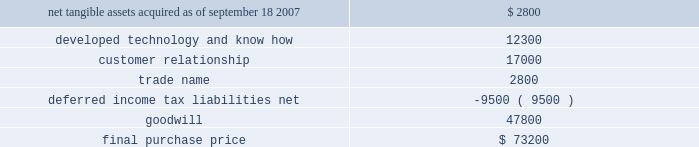Hologic , inc .
Notes to consolidated financial statements ( continued ) ( in thousands , except per share data ) fiscal 2007 acquisition : acquisition of biolucent , inc .
On september 18 , 2007 the company completed the acquisition of biolucent , inc .
( 201cbiolucent 201d ) pursuant to a definitive agreement dated june 20 , 2007 .
The results of operations for biolucent have been included in the company 2019s consolidated financial statements from the date of acquisition as part of its mammography/breast care business segment .
The company has concluded that the acquisition of biolucent does not represent a material business combination and therefore no pro forma financial information has been provided herein .
Biolucent , previously located in aliso viejo , california , develops , markets and sells mammopad breast cushions to decrease the discomfort associated with mammography .
Prior to the acquisition , biolucent 2019s primary research and development efforts were directed at its brachytherapy business which was focused on breast cancer therapy .
Prior to the acquisition , biolucent spun-off its brachytherapy technology and business to the holders of biolucent 2019s outstanding shares of capital stock .
As a result , the company only acquired biolucent 2019s mammopad cushion business and related assets .
The company invested $ 1000 directly in the spun-off brachytherapy business in exchange for shares of preferred stock issued by the new business .
The aggregate purchase price for biolucent was approximately $ 73200 , consisting of approximately $ 6800 in cash and 2314 shares of hologic common stock valued at approximately $ 63200 , debt assumed and paid off of approximately $ 1600 and approximately $ 1600 for acquisition related fees and expenses .
The company determined the fair value of the shares issued in connection with the acquisition in accordance with eitf issue no .
99-12 , determination of the measurement date for the market price of acquirer securities issued in a purchase business combination .
The acquisition also provides for up to two annual earn-out payments not to exceed $ 15000 in the aggregate based on biolucent 2019s achievement of certain revenue targets .
The company has considered the provision of eitf issue no .
95-8 , accounting for contingent consideration paid to the shareholders of an acquired enterprise in a purchase business combination , and concluded that this contingent consideration will represent additional purchase price .
As a result , goodwill will be increased by the amount of the additional consideration , if any , when it becomes due and payable .
As of september 27 , 2008 , the company has not recorded any amounts for these potential earn-outs .
The allocation of the purchase price is based upon estimates of the fair value of assets acquired and liabilities assumed as of september 18 , 2007 .
The components and allocation of the purchase price consists of the following approximate amounts: .
As part of the purchase price allocation , all intangible assets that were a part of the acquisition were identified and valued .
It was determined that only customer relationship , trade name and developed technology and know-how had separately identifiable values .
The fair value of these intangible assets was determined through the application of the income approach .
Customer relationship represents a large customer base that is expected to purchase the disposable mammopad product on a regular basis .
Trade name represents the .
What is the estimated price of hologic common stock used in the transaction for biolucent acquisition? 
Computations: (63200 / 2314)
Answer: 27.31201. 